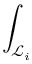Convert formula to latex. <formula><loc_0><loc_0><loc_500><loc_500>\int _ { \mathcal { L } _ { i } }</formula> 